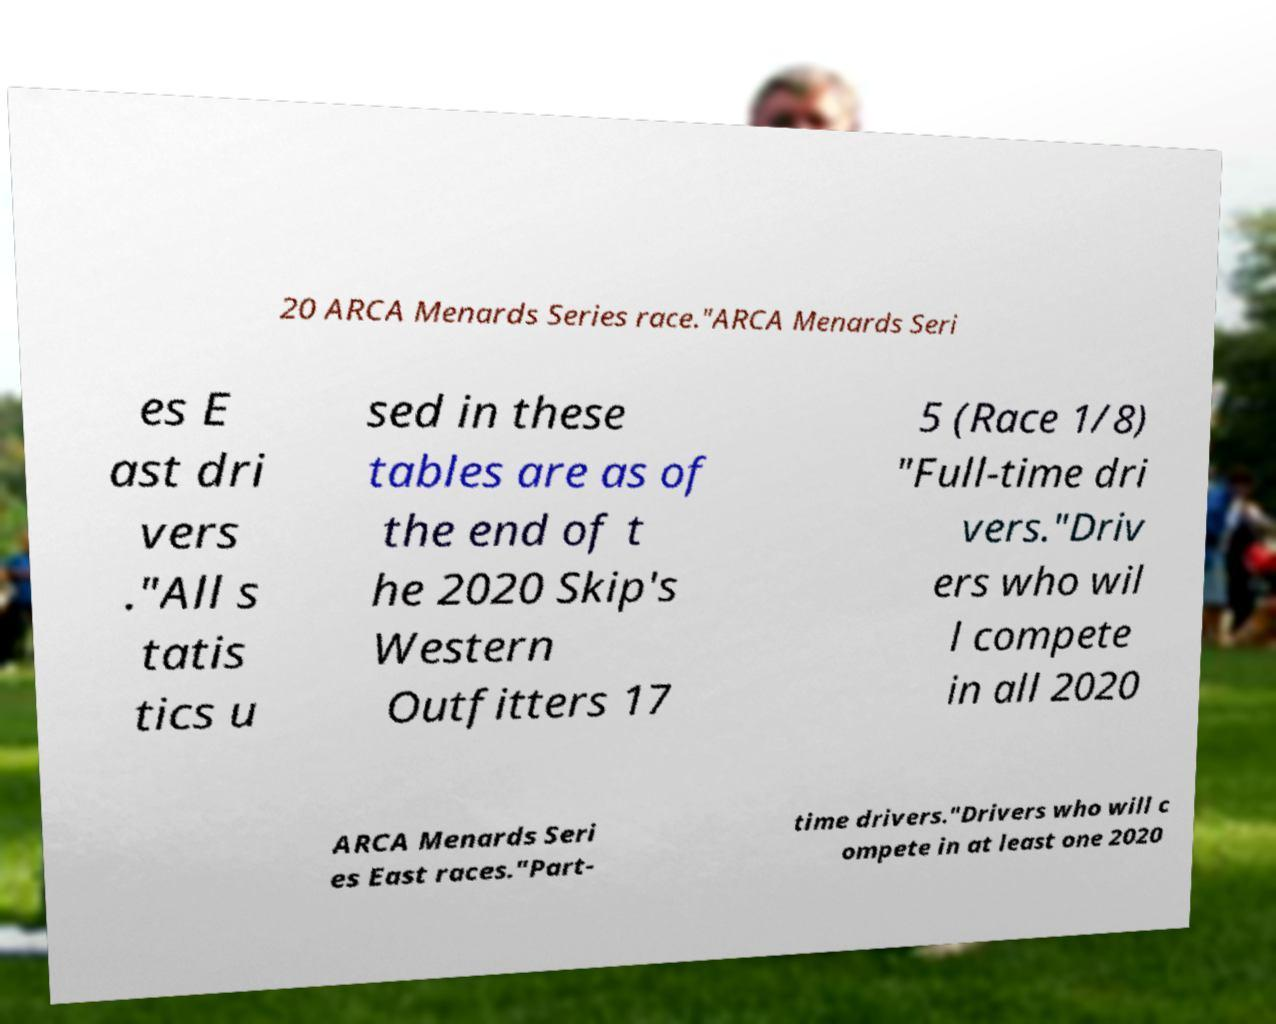Could you assist in decoding the text presented in this image and type it out clearly? 20 ARCA Menards Series race."ARCA Menards Seri es E ast dri vers ."All s tatis tics u sed in these tables are as of the end of t he 2020 Skip's Western Outfitters 17 5 (Race 1/8) "Full-time dri vers."Driv ers who wil l compete in all 2020 ARCA Menards Seri es East races."Part- time drivers."Drivers who will c ompete in at least one 2020 